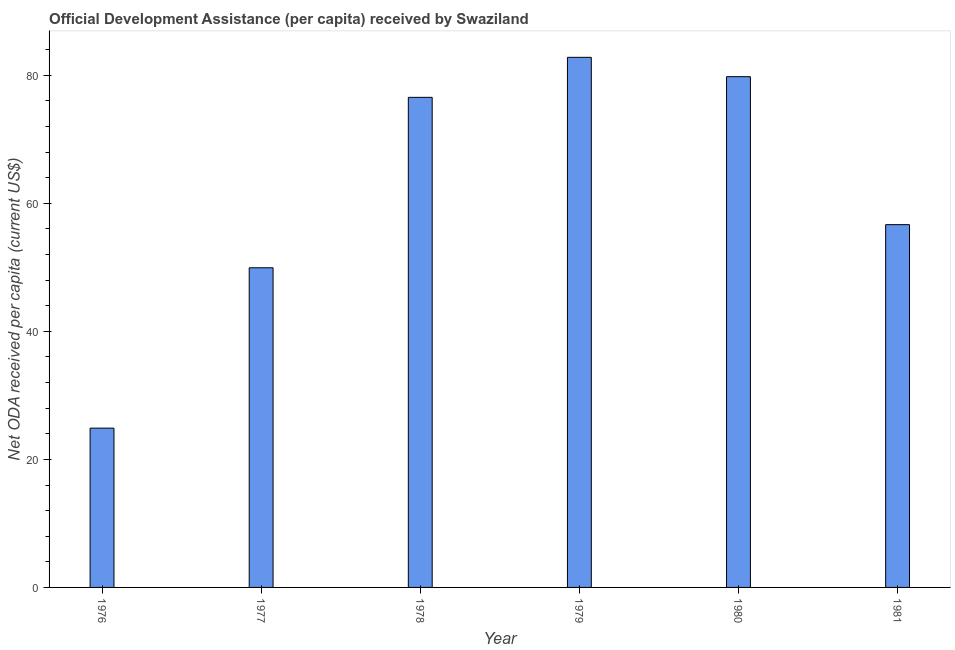What is the title of the graph?
Offer a very short reply. Official Development Assistance (per capita) received by Swaziland. What is the label or title of the Y-axis?
Keep it short and to the point. Net ODA received per capita (current US$). What is the net oda received per capita in 1977?
Provide a succinct answer. 49.93. Across all years, what is the maximum net oda received per capita?
Give a very brief answer. 82.81. Across all years, what is the minimum net oda received per capita?
Ensure brevity in your answer.  24.88. In which year was the net oda received per capita maximum?
Keep it short and to the point. 1979. In which year was the net oda received per capita minimum?
Your response must be concise. 1976. What is the sum of the net oda received per capita?
Keep it short and to the point. 370.64. What is the difference between the net oda received per capita in 1978 and 1980?
Provide a succinct answer. -3.23. What is the average net oda received per capita per year?
Provide a short and direct response. 61.77. What is the median net oda received per capita?
Your answer should be compact. 66.61. Do a majority of the years between 1979 and 1981 (inclusive) have net oda received per capita greater than 24 US$?
Offer a terse response. Yes. What is the ratio of the net oda received per capita in 1976 to that in 1981?
Provide a succinct answer. 0.44. Is the net oda received per capita in 1976 less than that in 1979?
Make the answer very short. Yes. Is the difference between the net oda received per capita in 1977 and 1979 greater than the difference between any two years?
Make the answer very short. No. What is the difference between the highest and the second highest net oda received per capita?
Make the answer very short. 3.02. Is the sum of the net oda received per capita in 1977 and 1979 greater than the maximum net oda received per capita across all years?
Give a very brief answer. Yes. What is the difference between the highest and the lowest net oda received per capita?
Make the answer very short. 57.92. How many years are there in the graph?
Your answer should be very brief. 6. What is the Net ODA received per capita (current US$) in 1976?
Provide a short and direct response. 24.88. What is the Net ODA received per capita (current US$) in 1977?
Offer a very short reply. 49.93. What is the Net ODA received per capita (current US$) of 1978?
Ensure brevity in your answer.  76.56. What is the Net ODA received per capita (current US$) of 1979?
Provide a short and direct response. 82.81. What is the Net ODA received per capita (current US$) in 1980?
Make the answer very short. 79.78. What is the Net ODA received per capita (current US$) in 1981?
Keep it short and to the point. 56.67. What is the difference between the Net ODA received per capita (current US$) in 1976 and 1977?
Make the answer very short. -25.05. What is the difference between the Net ODA received per capita (current US$) in 1976 and 1978?
Offer a terse response. -51.67. What is the difference between the Net ODA received per capita (current US$) in 1976 and 1979?
Offer a very short reply. -57.92. What is the difference between the Net ODA received per capita (current US$) in 1976 and 1980?
Offer a very short reply. -54.9. What is the difference between the Net ODA received per capita (current US$) in 1976 and 1981?
Ensure brevity in your answer.  -31.79. What is the difference between the Net ODA received per capita (current US$) in 1977 and 1978?
Your response must be concise. -26.62. What is the difference between the Net ODA received per capita (current US$) in 1977 and 1979?
Make the answer very short. -32.87. What is the difference between the Net ODA received per capita (current US$) in 1977 and 1980?
Give a very brief answer. -29.85. What is the difference between the Net ODA received per capita (current US$) in 1977 and 1981?
Offer a terse response. -6.74. What is the difference between the Net ODA received per capita (current US$) in 1978 and 1979?
Provide a succinct answer. -6.25. What is the difference between the Net ODA received per capita (current US$) in 1978 and 1980?
Your answer should be very brief. -3.23. What is the difference between the Net ODA received per capita (current US$) in 1978 and 1981?
Your answer should be compact. 19.89. What is the difference between the Net ODA received per capita (current US$) in 1979 and 1980?
Provide a short and direct response. 3.02. What is the difference between the Net ODA received per capita (current US$) in 1979 and 1981?
Keep it short and to the point. 26.14. What is the difference between the Net ODA received per capita (current US$) in 1980 and 1981?
Provide a short and direct response. 23.11. What is the ratio of the Net ODA received per capita (current US$) in 1976 to that in 1977?
Give a very brief answer. 0.5. What is the ratio of the Net ODA received per capita (current US$) in 1976 to that in 1978?
Provide a succinct answer. 0.33. What is the ratio of the Net ODA received per capita (current US$) in 1976 to that in 1979?
Make the answer very short. 0.3. What is the ratio of the Net ODA received per capita (current US$) in 1976 to that in 1980?
Provide a short and direct response. 0.31. What is the ratio of the Net ODA received per capita (current US$) in 1976 to that in 1981?
Keep it short and to the point. 0.44. What is the ratio of the Net ODA received per capita (current US$) in 1977 to that in 1978?
Offer a terse response. 0.65. What is the ratio of the Net ODA received per capita (current US$) in 1977 to that in 1979?
Ensure brevity in your answer.  0.6. What is the ratio of the Net ODA received per capita (current US$) in 1977 to that in 1980?
Offer a very short reply. 0.63. What is the ratio of the Net ODA received per capita (current US$) in 1977 to that in 1981?
Offer a terse response. 0.88. What is the ratio of the Net ODA received per capita (current US$) in 1978 to that in 1979?
Offer a terse response. 0.93. What is the ratio of the Net ODA received per capita (current US$) in 1978 to that in 1981?
Your response must be concise. 1.35. What is the ratio of the Net ODA received per capita (current US$) in 1979 to that in 1980?
Your response must be concise. 1.04. What is the ratio of the Net ODA received per capita (current US$) in 1979 to that in 1981?
Provide a short and direct response. 1.46. What is the ratio of the Net ODA received per capita (current US$) in 1980 to that in 1981?
Provide a succinct answer. 1.41. 